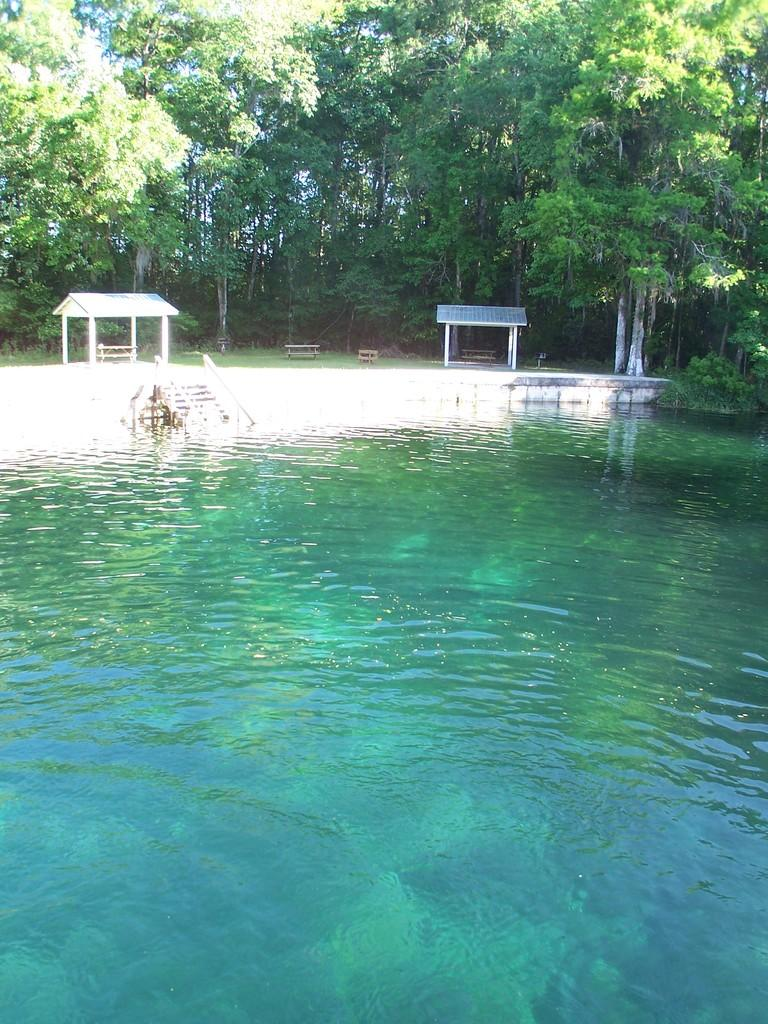What is visible in the image? Water, stairs, rods, sheds, wooden objects, and trees are visible in the image. Can you describe the stairs in the image? The image shows stairs, but their specific details are not clear. What type of objects are made of wood in the image? There are wooden sheds and possibly other wooden objects in the image. What is visible in the background of the image? Trees are visible in the background of the image. What news is being reported on the club in the image? There is no club or news reporting present in the image. How is the ice being used in the image? There is no ice present in the image. 